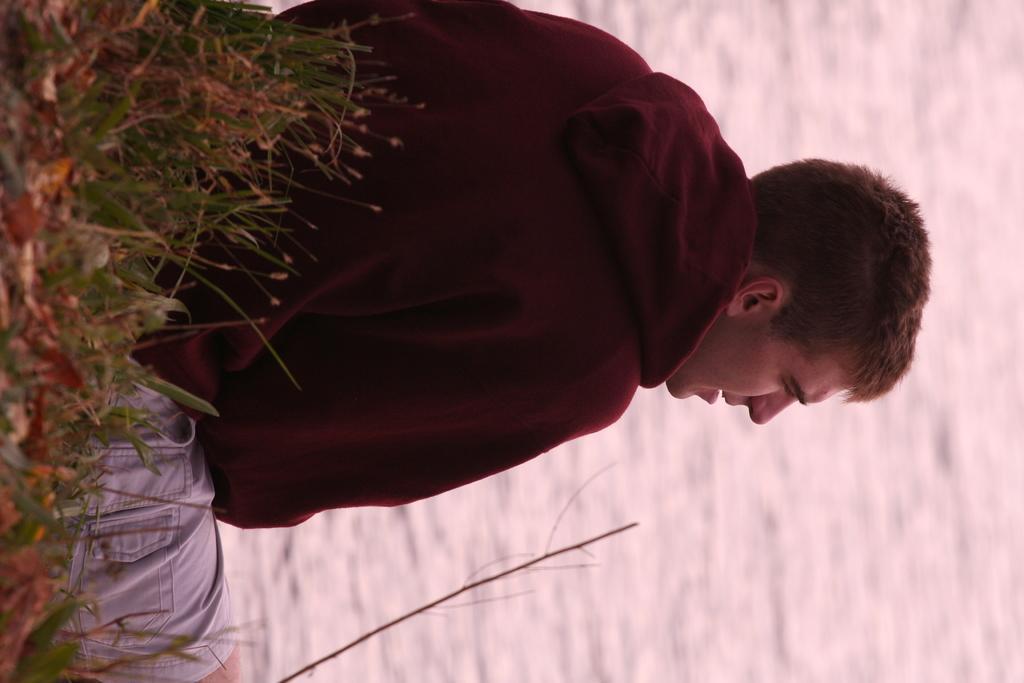Can you describe this image briefly? In the center of the picture there is a person sitting. On the left there are shrubs and grass. On the right there is a water body. 